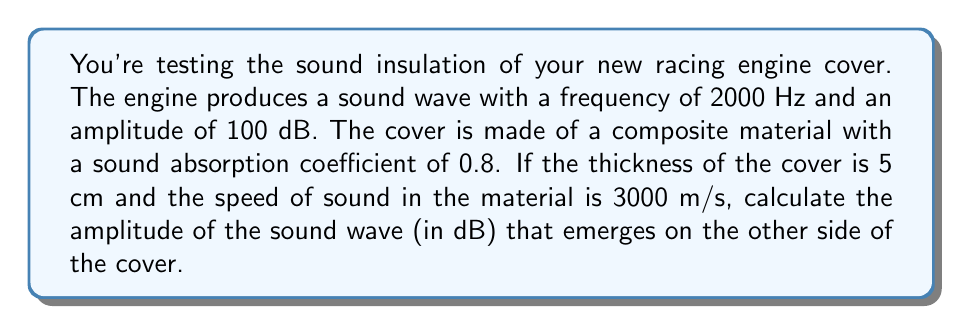Give your solution to this math problem. Let's approach this step-by-step:

1) First, we need to calculate the wavelength of the sound in the material:
   $$\lambda = \frac{v}{f}$$
   where $v$ is the speed of sound in the material and $f$ is the frequency.
   $$\lambda = \frac{3000 \text{ m/s}}{2000 \text{ Hz}} = 1.5 \text{ m}$$

2) Next, we need to calculate how many wavelengths the sound travels through the material:
   $$\text{Number of wavelengths} = \frac{\text{Thickness}}{\lambda} = \frac{0.05 \text{ m}}{1.5 \text{ m}} = 0.0333$$

3) The amplitude reduction factor due to absorption is given by:
   $$R = (1-\alpha)^{n}$$
   where $\alpha$ is the absorption coefficient and $n$ is the number of wavelengths.
   $$R = (1-0.8)^{0.0333} = 0.9277$$

4) The reduction in decibels is:
   $$\text{Reduction (dB)} = -20 \log_{10}(R) = -20 \log_{10}(0.9277) = 0.6507 \text{ dB}$$

5) Therefore, the final amplitude is:
   $$100 \text{ dB} - 0.6507 \text{ dB} = 99.3493 \text{ dB}$$
Answer: 99.35 dB 